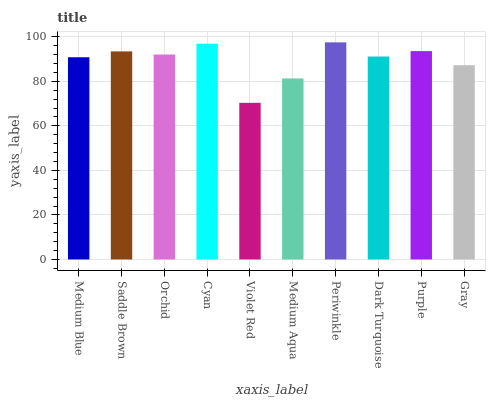Is Violet Red the minimum?
Answer yes or no. Yes. Is Periwinkle the maximum?
Answer yes or no. Yes. Is Saddle Brown the minimum?
Answer yes or no. No. Is Saddle Brown the maximum?
Answer yes or no. No. Is Saddle Brown greater than Medium Blue?
Answer yes or no. Yes. Is Medium Blue less than Saddle Brown?
Answer yes or no. Yes. Is Medium Blue greater than Saddle Brown?
Answer yes or no. No. Is Saddle Brown less than Medium Blue?
Answer yes or no. No. Is Orchid the high median?
Answer yes or no. Yes. Is Dark Turquoise the low median?
Answer yes or no. Yes. Is Saddle Brown the high median?
Answer yes or no. No. Is Medium Blue the low median?
Answer yes or no. No. 